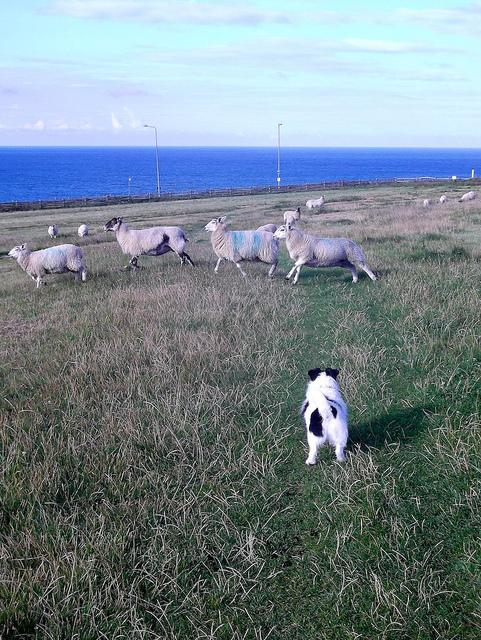What are the blue marks from? paint 